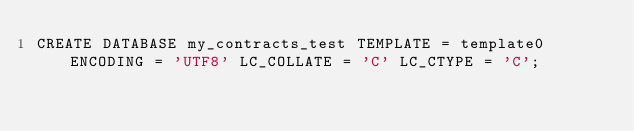Convert code to text. <code><loc_0><loc_0><loc_500><loc_500><_SQL_>CREATE DATABASE my_contracts_test TEMPLATE = template0 ENCODING = 'UTF8' LC_COLLATE = 'C' LC_CTYPE = 'C';
</code> 